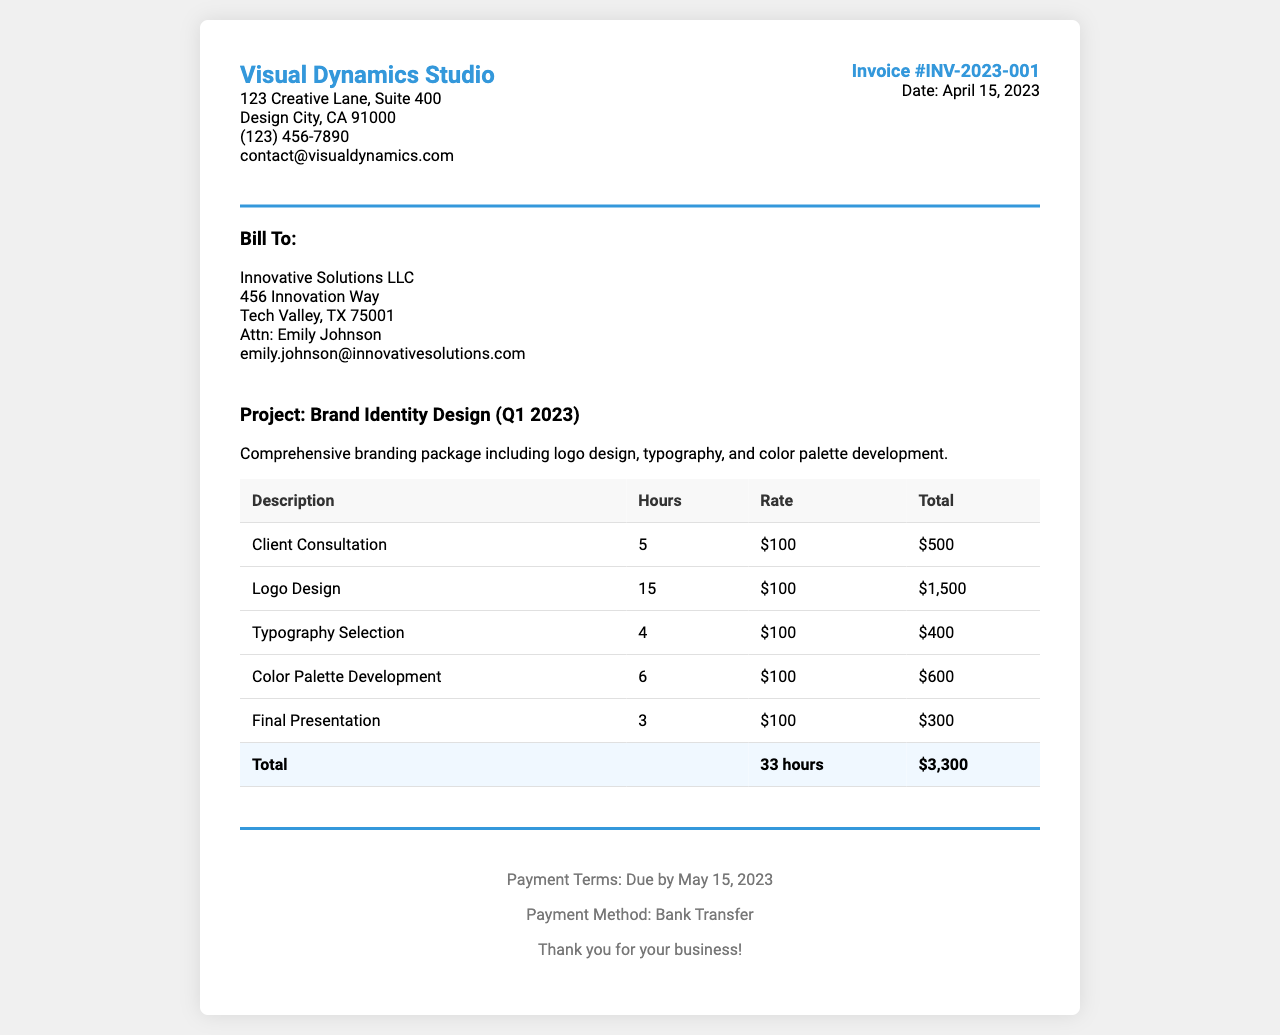What is the invoice number? The invoice number is identified at the top right of the invoice document.
Answer: INV-2023-001 What is the total amount billed? The total amount billed is presented in the total row at the bottom of the itemized list.
Answer: $3,300 How many hours were billed for the logo design? The hours billed for logo design is provided in the itemized breakdown of services.
Answer: 15 Who is the client representative listed on the invoice? The client representative's name is shown in the client details section of the document.
Answer: Emily Johnson What is the payment due date? The payment due date is specified in the payment terms section of the invoice.
Answer: May 15, 2023 What project is being billed? The project name is mentioned in the project section, detailing what the invoice covers.
Answer: Brand Identity Design (Q1 2023) How many total hours were worked on the project? The total hours worked is the sum of all hours in the itemized table.
Answer: 33 hours What is the hourly rate for the services rendered? The hourly rate is mentioned in each row of the itemized services and totals.
Answer: $100 What is the payment method listed in the invoice? The payment method can be found in the payment terms section.
Answer: Bank Transfer 